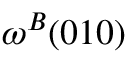<formula> <loc_0><loc_0><loc_500><loc_500>\omega ^ { B } ( 0 1 0 )</formula> 